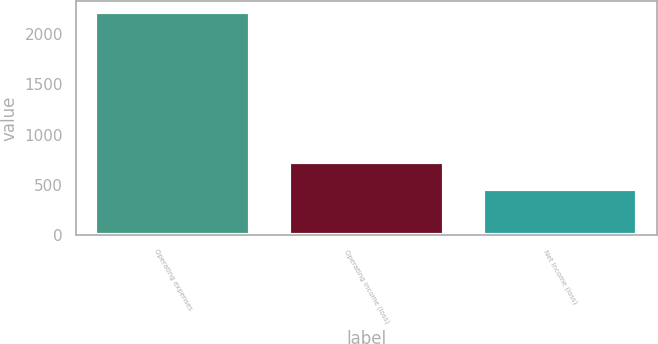Convert chart to OTSL. <chart><loc_0><loc_0><loc_500><loc_500><bar_chart><fcel>Operating expenses<fcel>Operating income (loss)<fcel>Net income (loss)<nl><fcel>2218<fcel>730<fcel>455<nl></chart> 